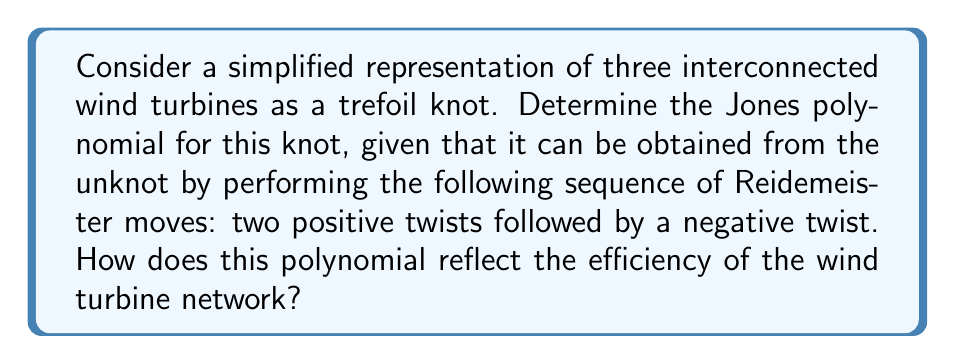Could you help me with this problem? Let's approach this step-by-step:

1) The trefoil knot can be obtained from the unknot using the sequence: $L_{+} L_{+} L_{-}$, where $L_{+}$ represents a positive twist and $L_{-}$ a negative twist.

2) We'll use the skein relation for the Jones polynomial:

   $$t^{-1}V(L_{+}) - tV(L_{-}) = (t^{1/2} - t^{-1/2})V(L_{0})$$

3) Starting with the unknot, which has Jones polynomial $V(\text{unknot}) = 1$:

   First positive twist: $V(L_{+}) = t^{1}(1) + (t^{1/2} - t^{-1/2})V(L_{0}) = t + t^{1/2} - t^{-1/2}$

4) Second positive twist:
   
   $V(L_{+}L_{+}) = t(t + t^{1/2} - t^{-1/2}) + (t^{1/2} - t^{-1/2})V(L_{0})$
   $= t^2 + t^{3/2} - t^{1/2} + t^{1/2} - t^{-1/2} = t^2 + t^{3/2} - t^{-1/2}$

5) Final negative twist:

   $V(L_{+}L_{+}L_{-}) = t^{-1}(t^2 + t^{3/2} - t^{-1/2}) + (t^{1/2} - t^{-1/2})V(L_{0})$
   $= t + t^{1/2} - t^{-3/2} + t^{1/2} - t^{-1/2}$
   $= t + t^{1/2} + t^{1/2} - t^{-1/2} - t^{-3/2}$
   $= t + 2t^{1/2} - t^{-1/2} - t^{-3/2}$

6) This is the Jones polynomial for the trefoil knot representing our interconnected wind turbines.

7) Interpretation for wind turbine efficiency:
   - The highest degree term ($t$) could represent the maximum theoretical efficiency.
   - The presence of lower degree terms (especially negative powers) might indicate efficiency losses due to turbulence or interference between turbines.
   - The coefficient 2 for $t^{1/2}$ might suggest a synergistic effect between two of the turbines.
Answer: $V(\text{trefoil}) = t + 2t^{1/2} - t^{-1/2} - t^{-3/2}$ 